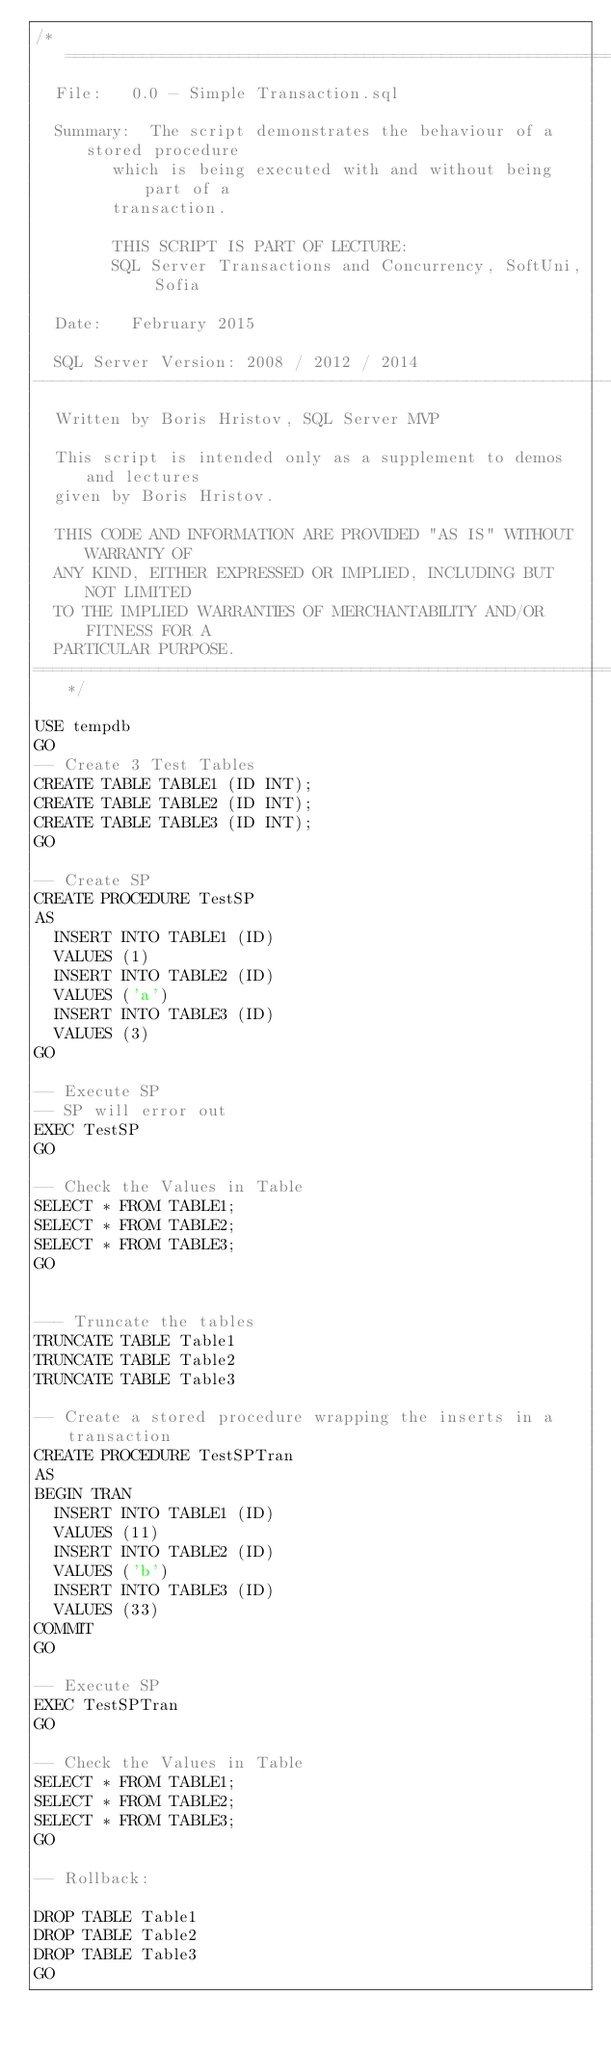<code> <loc_0><loc_0><loc_500><loc_500><_SQL_>/*============================================================================
	File:		0.0 - Simple Transaction.sql

	Summary:	The script demonstrates the behaviour of a stored procedure
				which is being executed with and without being part of a 
				transaction.

				THIS SCRIPT IS PART OF LECTURE: 
				SQL Server Transactions and Concurrency, SoftUni, Sofia

	Date:		February 2015

	SQL Server Version: 2008 / 2012 / 2014
------------------------------------------------------------------------------
	Written by Boris Hristov, SQL Server MVP

	This script is intended only as a supplement to demos and lectures
	given by Boris Hristov.  
  
	THIS CODE AND INFORMATION ARE PROVIDED "AS IS" WITHOUT WARRANTY OF 
	ANY KIND, EITHER EXPRESSED OR IMPLIED, INCLUDING BUT NOT LIMITED 
	TO THE IMPLIED WARRANTIES OF MERCHANTABILITY AND/OR FITNESS FOR A
	PARTICULAR PURPOSE.
============================================================================*/

USE tempdb
GO
-- Create 3 Test Tables
CREATE TABLE TABLE1 (ID INT);
CREATE TABLE TABLE2 (ID INT);
CREATE TABLE TABLE3 (ID INT);
GO

-- Create SP
CREATE PROCEDURE TestSP
AS
	INSERT INTO TABLE1 (ID)
	VALUES (1)
	INSERT INTO TABLE2 (ID)
	VALUES ('a')
	INSERT INTO TABLE3 (ID)
	VALUES (3)
GO

-- Execute SP
-- SP will error out
EXEC TestSP
GO

-- Check the Values in Table
SELECT * FROM TABLE1;
SELECT * FROM TABLE2;
SELECT * FROM TABLE3;
GO


--- Truncate the tables
TRUNCATE TABLE Table1
TRUNCATE TABLE Table2
TRUNCATE TABLE Table3

-- Create a stored procedure wrapping the inserts in a transaction
CREATE PROCEDURE TestSPTran
AS
BEGIN TRAN
	INSERT INTO TABLE1 (ID)
	VALUES (11)
	INSERT INTO TABLE2 (ID)
	VALUES ('b')
	INSERT INTO TABLE3 (ID)
	VALUES (33)
COMMIT
GO

-- Execute SP
EXEC TestSPTran
GO

-- Check the Values in Table
SELECT * FROM TABLE1;
SELECT * FROM TABLE2;
SELECT * FROM TABLE3;
GO

-- Rollback:

DROP TABLE Table1
DROP TABLE Table2
DROP TABLE Table3
GO</code> 